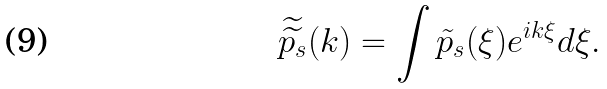Convert formula to latex. <formula><loc_0><loc_0><loc_500><loc_500>\widetilde { \widetilde { p _ { s } } } ( k ) = \int \tilde { p } _ { s } ( \xi ) e ^ { i k \xi } d \xi .</formula> 